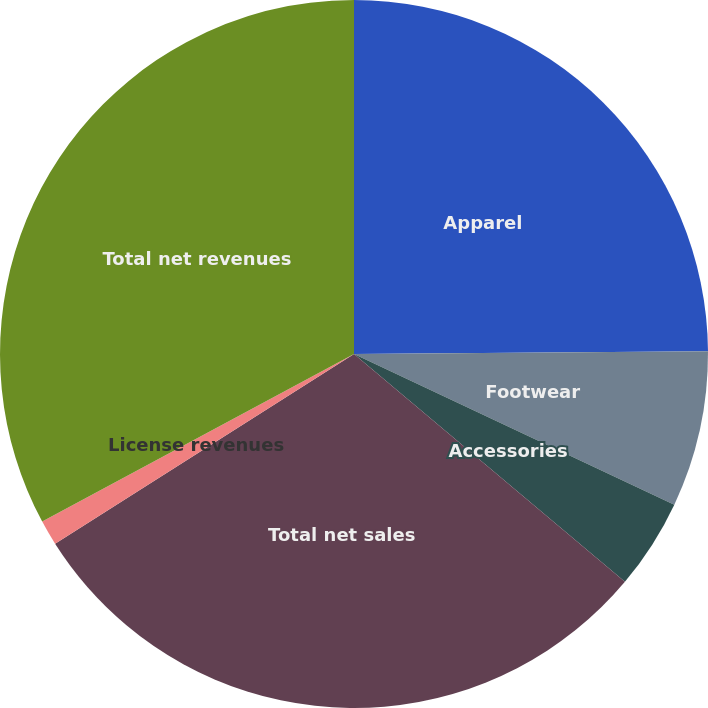<chart> <loc_0><loc_0><loc_500><loc_500><pie_chart><fcel>Apparel<fcel>Footwear<fcel>Accessories<fcel>Total net sales<fcel>License revenues<fcel>Total net revenues<nl><fcel>24.88%<fcel>7.12%<fcel>4.13%<fcel>29.87%<fcel>1.15%<fcel>32.85%<nl></chart> 